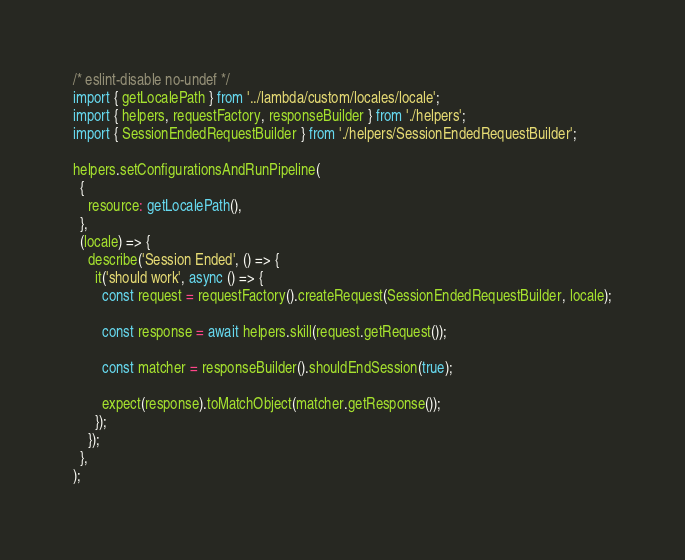Convert code to text. <code><loc_0><loc_0><loc_500><loc_500><_TypeScript_>/* eslint-disable no-undef */
import { getLocalePath } from '../lambda/custom/locales/locale';
import { helpers, requestFactory, responseBuilder } from './helpers';
import { SessionEndedRequestBuilder } from './helpers/SessionEndedRequestBuilder';

helpers.setConfigurationsAndRunPipeline(
  {
    resource: getLocalePath(),
  },
  (locale) => {
    describe('Session Ended', () => {
      it('should work', async () => {
        const request = requestFactory().createRequest(SessionEndedRequestBuilder, locale);

        const response = await helpers.skill(request.getRequest());

        const matcher = responseBuilder().shouldEndSession(true);

        expect(response).toMatchObject(matcher.getResponse());
      });
    });
  },
);
</code> 